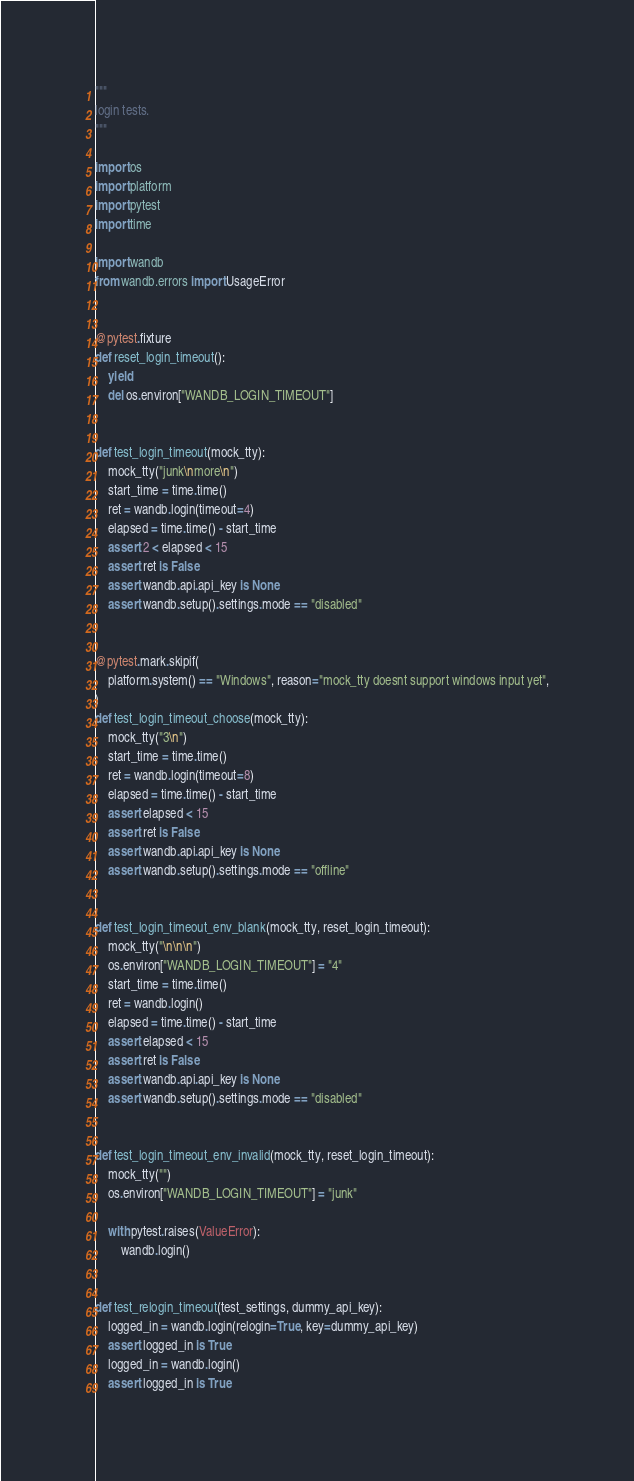Convert code to text. <code><loc_0><loc_0><loc_500><loc_500><_Python_>"""
login tests.
"""

import os
import platform
import pytest
import time

import wandb
from wandb.errors import UsageError


@pytest.fixture
def reset_login_timeout():
    yield
    del os.environ["WANDB_LOGIN_TIMEOUT"]


def test_login_timeout(mock_tty):
    mock_tty("junk\nmore\n")
    start_time = time.time()
    ret = wandb.login(timeout=4)
    elapsed = time.time() - start_time
    assert 2 < elapsed < 15
    assert ret is False
    assert wandb.api.api_key is None
    assert wandb.setup().settings.mode == "disabled"


@pytest.mark.skipif(
    platform.system() == "Windows", reason="mock_tty doesnt support windows input yet",
)
def test_login_timeout_choose(mock_tty):
    mock_tty("3\n")
    start_time = time.time()
    ret = wandb.login(timeout=8)
    elapsed = time.time() - start_time
    assert elapsed < 15
    assert ret is False
    assert wandb.api.api_key is None
    assert wandb.setup().settings.mode == "offline"


def test_login_timeout_env_blank(mock_tty, reset_login_timeout):
    mock_tty("\n\n\n")
    os.environ["WANDB_LOGIN_TIMEOUT"] = "4"
    start_time = time.time()
    ret = wandb.login()
    elapsed = time.time() - start_time
    assert elapsed < 15
    assert ret is False
    assert wandb.api.api_key is None
    assert wandb.setup().settings.mode == "disabled"


def test_login_timeout_env_invalid(mock_tty, reset_login_timeout):
    mock_tty("")
    os.environ["WANDB_LOGIN_TIMEOUT"] = "junk"

    with pytest.raises(ValueError):
        wandb.login()


def test_relogin_timeout(test_settings, dummy_api_key):
    logged_in = wandb.login(relogin=True, key=dummy_api_key)
    assert logged_in is True
    logged_in = wandb.login()
    assert logged_in is True
</code> 